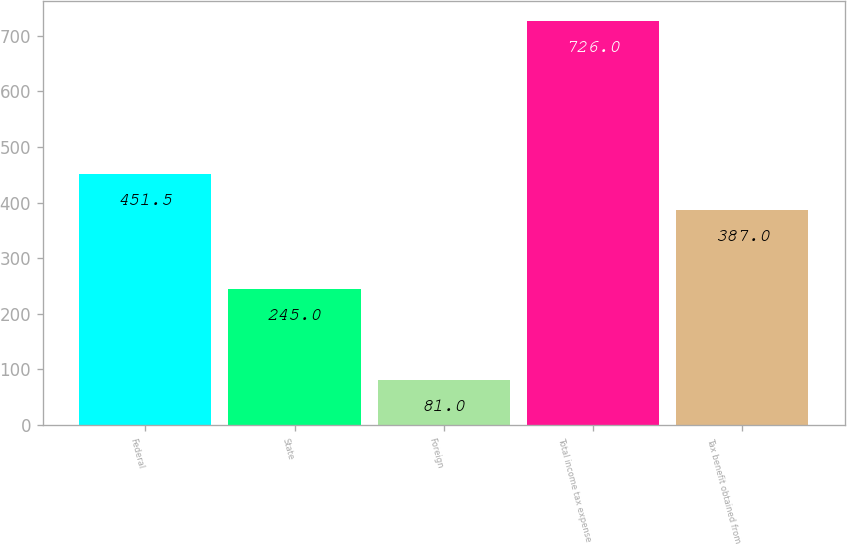<chart> <loc_0><loc_0><loc_500><loc_500><bar_chart><fcel>Federal<fcel>State<fcel>Foreign<fcel>Total income tax expense<fcel>Tax benefit obtained from<nl><fcel>451.5<fcel>245<fcel>81<fcel>726<fcel>387<nl></chart> 